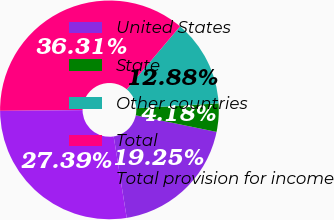<chart> <loc_0><loc_0><loc_500><loc_500><pie_chart><fcel>United States<fcel>State<fcel>Other countries<fcel>Total<fcel>Total provision for income<nl><fcel>19.25%<fcel>4.18%<fcel>12.88%<fcel>36.31%<fcel>27.39%<nl></chart> 